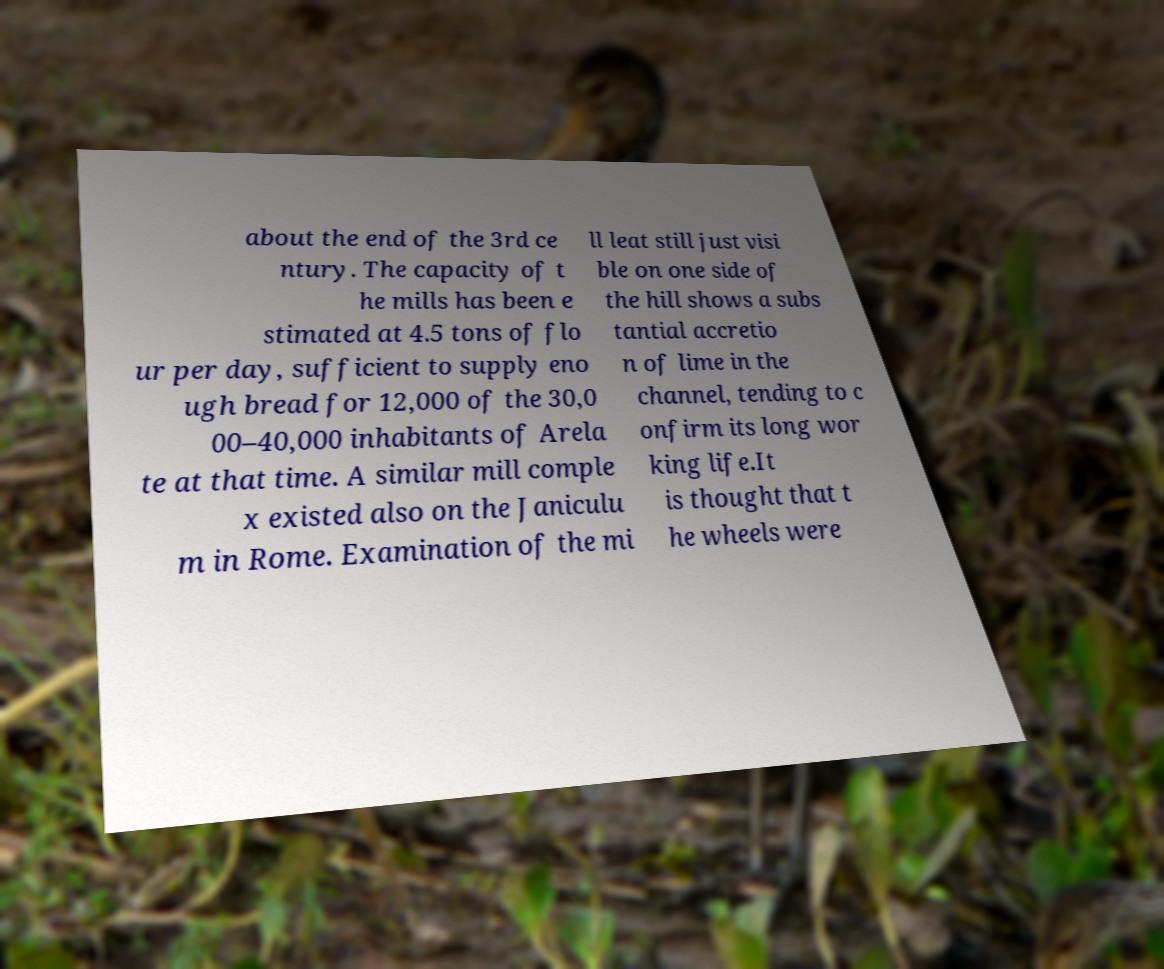Please read and relay the text visible in this image. What does it say? about the end of the 3rd ce ntury. The capacity of t he mills has been e stimated at 4.5 tons of flo ur per day, sufficient to supply eno ugh bread for 12,000 of the 30,0 00–40,000 inhabitants of Arela te at that time. A similar mill comple x existed also on the Janiculu m in Rome. Examination of the mi ll leat still just visi ble on one side of the hill shows a subs tantial accretio n of lime in the channel, tending to c onfirm its long wor king life.It is thought that t he wheels were 